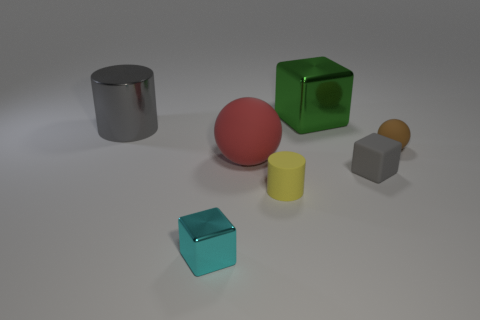Do the gray object behind the big red thing and the object that is in front of the tiny cylinder have the same material?
Make the answer very short. Yes. Is the number of large green metallic blocks that are in front of the big matte thing the same as the number of big gray metal cylinders that are behind the large gray cylinder?
Your answer should be compact. Yes. How many small yellow cylinders have the same material as the small cyan block?
Provide a short and direct response. 0. What shape is the large thing that is the same color as the rubber block?
Keep it short and to the point. Cylinder. There is a cylinder that is on the left side of the small cube that is to the left of the small gray matte thing; how big is it?
Provide a short and direct response. Large. There is a shiny object behind the large gray shiny object; does it have the same shape as the gray thing that is to the left of the large cube?
Offer a terse response. No. Are there an equal number of large red spheres right of the big red ball and small metallic cubes?
Make the answer very short. No. What is the color of the small metallic object that is the same shape as the large green object?
Your answer should be compact. Cyan. Does the red thing that is left of the yellow rubber object have the same material as the brown object?
Make the answer very short. Yes. How many small things are yellow matte things or brown matte objects?
Offer a very short reply. 2. 